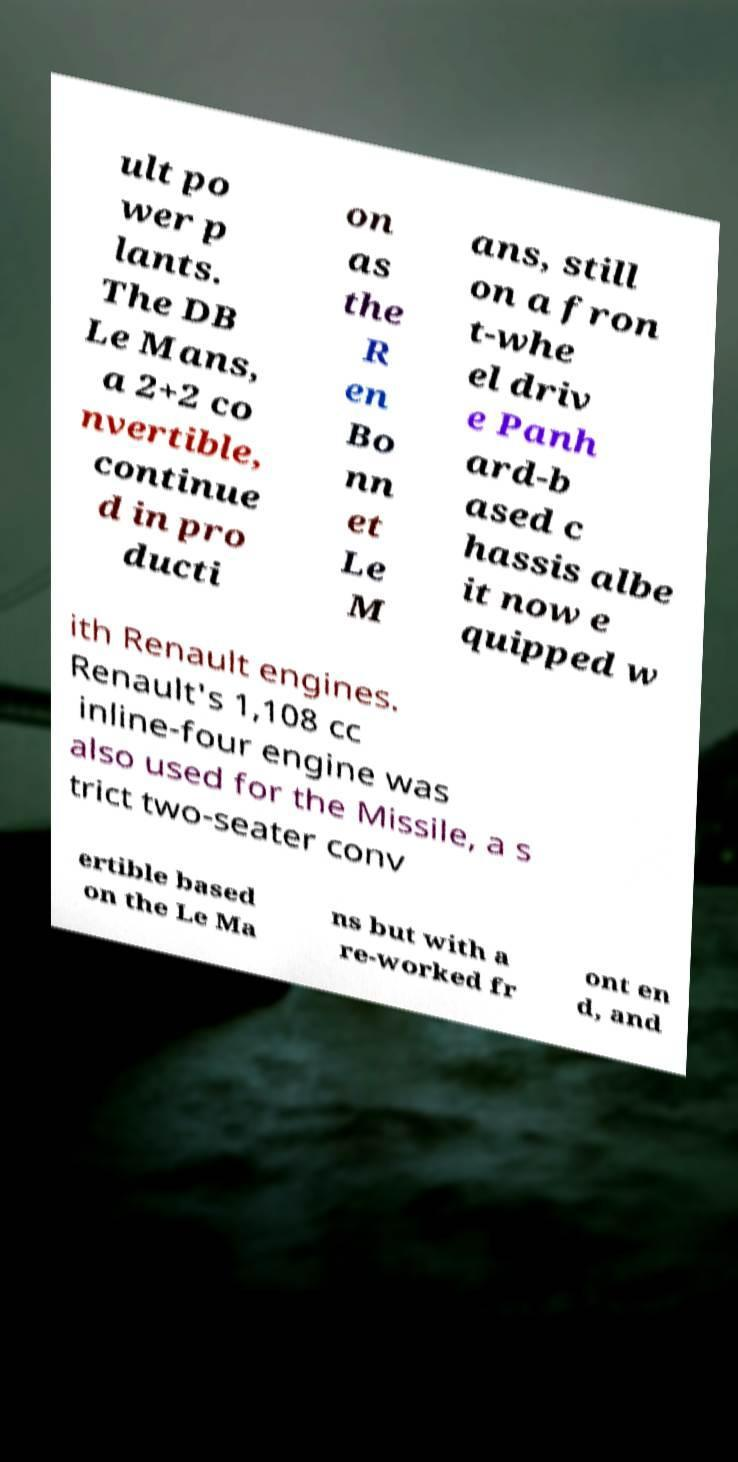Could you extract and type out the text from this image? ult po wer p lants. The DB Le Mans, a 2+2 co nvertible, continue d in pro ducti on as the R en Bo nn et Le M ans, still on a fron t-whe el driv e Panh ard-b ased c hassis albe it now e quipped w ith Renault engines. Renault's 1,108 cc inline-four engine was also used for the Missile, a s trict two-seater conv ertible based on the Le Ma ns but with a re-worked fr ont en d, and 